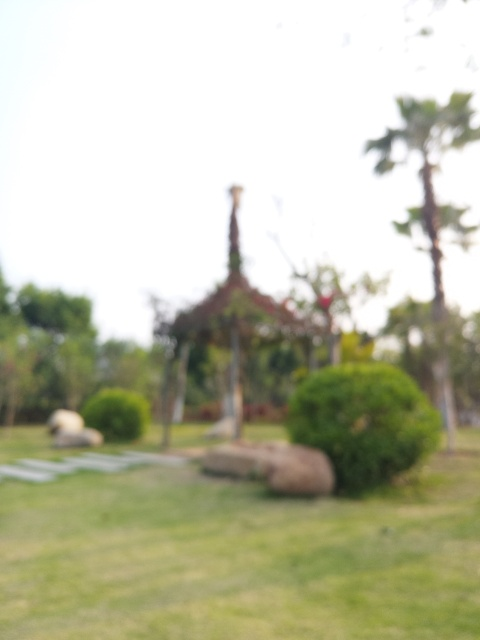What is the issue with the image quality? The image quality is suboptimal due to serious focus issues, which result in a significantly blurry picture. This makes it difficult to discern the finer details of the scene, such as textural nuances or specific features of the objects and potential subjects in view. 